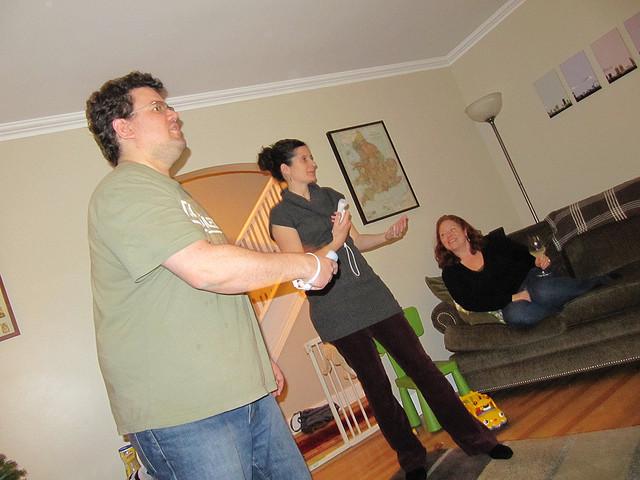Is there a lamp in the background?
Concise answer only. Yes. What kind of pants is he wearing?
Answer briefly. Jeans. What is the name of the game system being utilized?
Be succinct. Wii. What is the person wearing on their knees?
Be succinct. Pants. How many bags are there?
Give a very brief answer. 0. What piece of furniture are they sitting on?
Answer briefly. Couch. What are these people doing?
Answer briefly. Playing. How many picture frames are on the wall?
Quick response, please. 6. What instrument is the man using?
Keep it brief. Wii controller. What is around the man's wrist?
Give a very brief answer. Wii controller. What is the lady seated on the couch holding?
Quick response, please. Wine glass. 